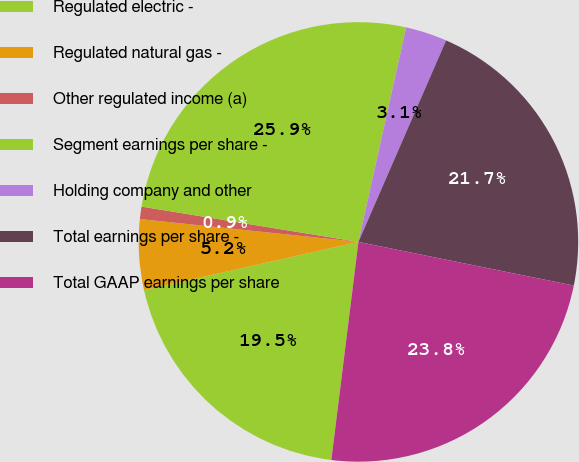Convert chart. <chart><loc_0><loc_0><loc_500><loc_500><pie_chart><fcel>Regulated electric -<fcel>Regulated natural gas -<fcel>Other regulated income (a)<fcel>Segment earnings per share -<fcel>Holding company and other<fcel>Total earnings per share -<fcel>Total GAAP earnings per share<nl><fcel>19.51%<fcel>5.18%<fcel>0.91%<fcel>25.91%<fcel>3.05%<fcel>21.65%<fcel>23.78%<nl></chart> 